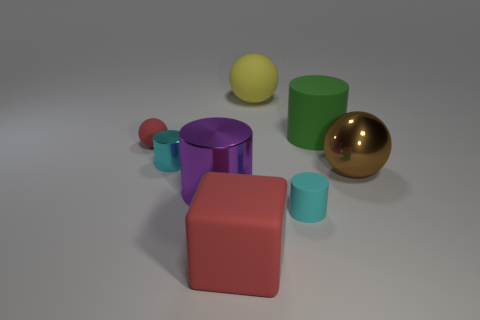Are there fewer cyan rubber things in front of the cyan matte object than large cylinders that are left of the big yellow matte object?
Your answer should be compact. Yes. What number of red objects are either big things or big cubes?
Provide a succinct answer. 1. Are there the same number of yellow spheres on the left side of the tiny red matte ball and small brown rubber balls?
Offer a terse response. Yes. What number of objects are either brown metal balls or spheres that are to the right of the yellow matte ball?
Give a very brief answer. 1. Does the small shiny thing have the same color as the tiny matte cylinder?
Offer a very short reply. Yes. Are there any cylinders that have the same material as the cube?
Offer a very short reply. Yes. There is another big metallic object that is the same shape as the large green thing; what color is it?
Make the answer very short. Purple. Is the small red ball made of the same material as the small cyan cylinder that is on the right side of the large red matte thing?
Your answer should be compact. Yes. There is a small rubber object in front of the small red object that is in front of the large yellow matte ball; what is its shape?
Provide a short and direct response. Cylinder. There is a red thing behind the red matte cube; does it have the same size as the big rubber cube?
Give a very brief answer. No. 